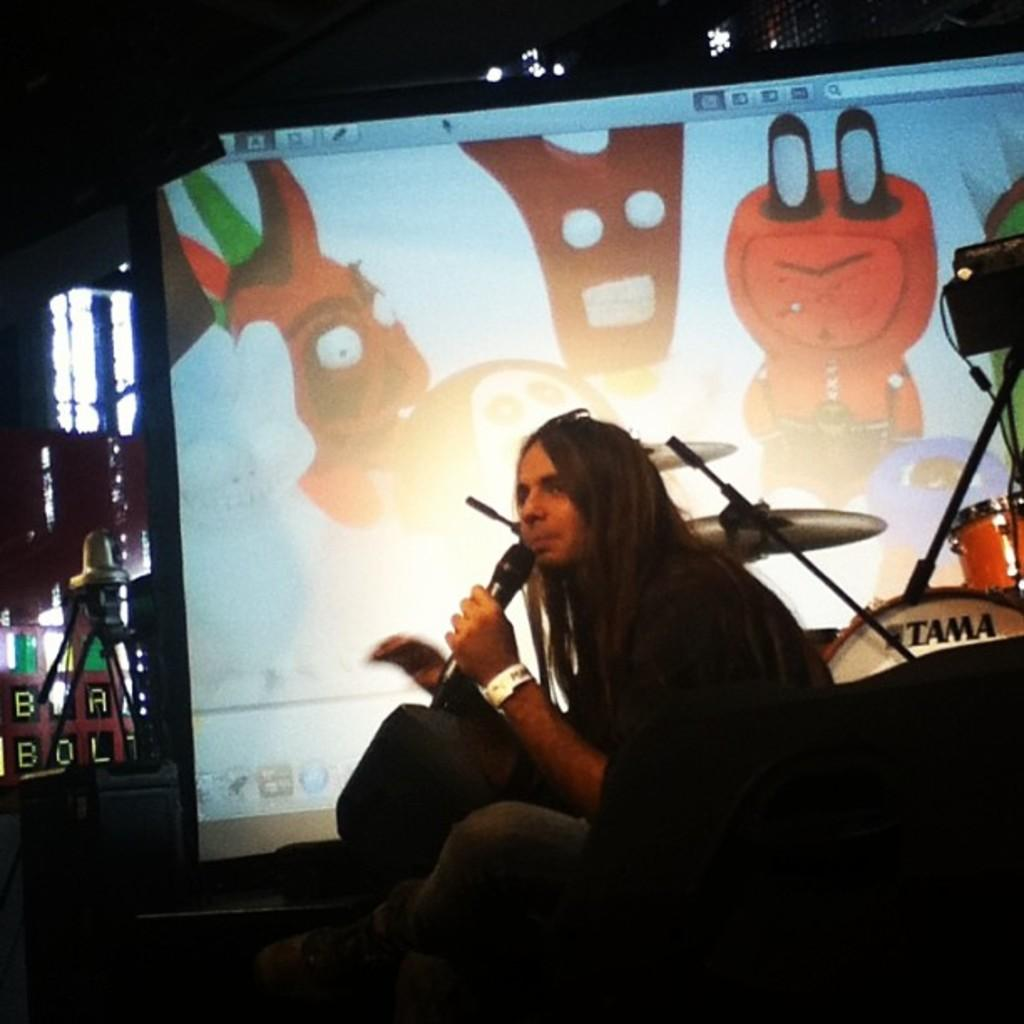What is the person in the image doing? The person is holding a microphone. What is the person's position in the image? The person is sitting. What can be seen in the background of the image? There is a screen and a drum kit in the background of the image, along with other objects and things. What type of crime is being committed in the image? There is no crime being committed in the image; it features a person holding a microphone and sitting. What scent can be detected from the image? There is no scent associated with the image, as it is a visual representation. 